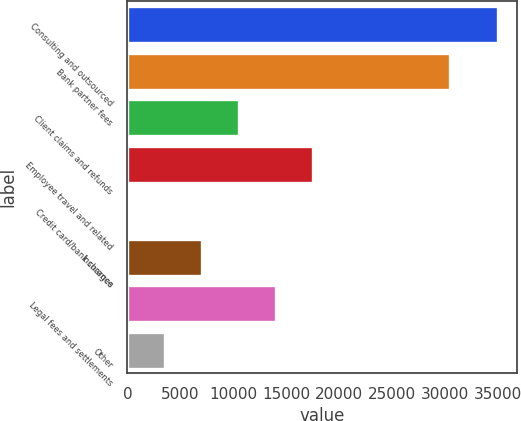<chart> <loc_0><loc_0><loc_500><loc_500><bar_chart><fcel>Consulting and outsourced<fcel>Bank partner fees<fcel>Client claims and refunds<fcel>Employee travel and related<fcel>Credit card/bank charges<fcel>Insurance<fcel>Legal fees and settlements<fcel>Other<nl><fcel>35057<fcel>30499<fcel>10545.1<fcel>17548.5<fcel>40<fcel>7043.4<fcel>14046.8<fcel>3541.7<nl></chart> 